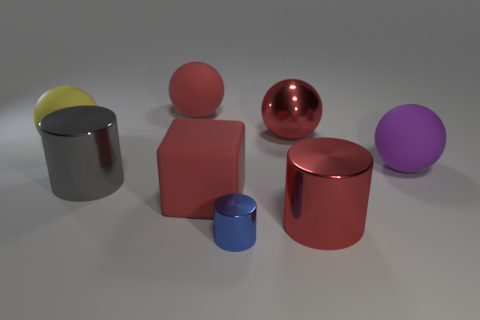Subtract all gray cylinders. How many red spheres are left? 2 Subtract all big shiny cylinders. How many cylinders are left? 1 Subtract 1 cylinders. How many cylinders are left? 2 Add 2 rubber cubes. How many objects exist? 10 Subtract all yellow spheres. How many spheres are left? 3 Subtract all green cylinders. Subtract all brown blocks. How many cylinders are left? 3 Subtract all cubes. How many objects are left? 7 Subtract 0 blue spheres. How many objects are left? 8 Subtract all small yellow matte objects. Subtract all matte blocks. How many objects are left? 7 Add 4 blue objects. How many blue objects are left? 5 